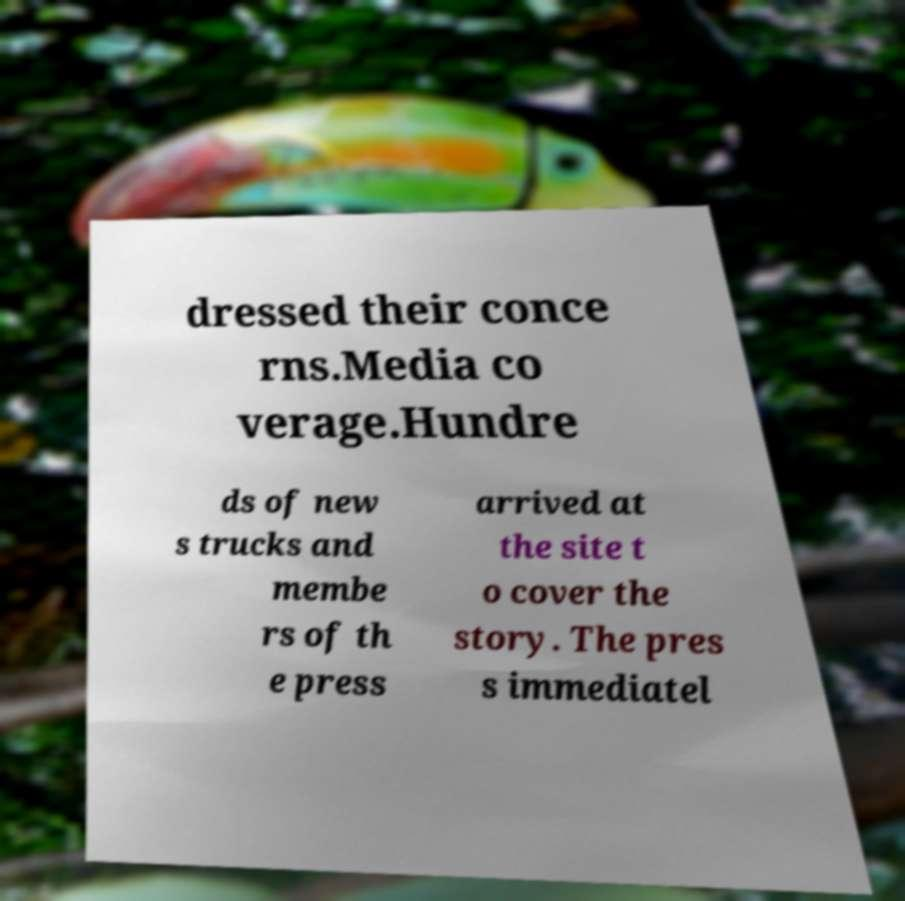Can you accurately transcribe the text from the provided image for me? dressed their conce rns.Media co verage.Hundre ds of new s trucks and membe rs of th e press arrived at the site t o cover the story. The pres s immediatel 